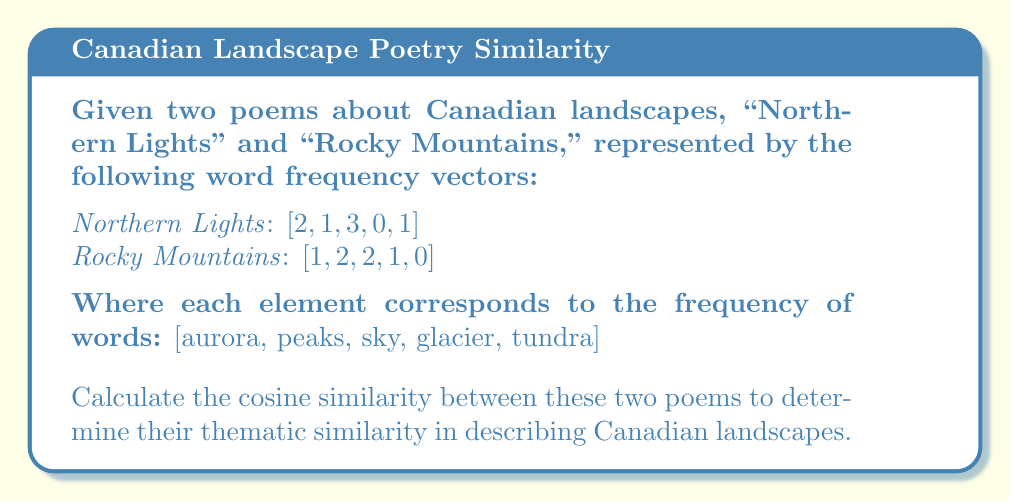Solve this math problem. To calculate the cosine similarity between the two poems, we'll follow these steps:

1. Let $\mathbf{a} = [2, 1, 3, 0, 1]$ represent "Northern Lights" and $\mathbf{b} = [1, 2, 2, 1, 0]$ represent "Rocky Mountains".

2. The cosine similarity is given by the formula:

   $$\text{cosine similarity} = \frac{\mathbf{a} \cdot \mathbf{b}}{\|\mathbf{a}\| \|\mathbf{b}\|}$$

3. Calculate the dot product $\mathbf{a} \cdot \mathbf{b}$:
   $$(2 \times 1) + (1 \times 2) + (3 \times 2) + (0 \times 1) + (1 \times 0) = 2 + 2 + 6 + 0 + 0 = 10$$

4. Calculate $\|\mathbf{a}\|$:
   $$\|\mathbf{a}\| = \sqrt{2^2 + 1^2 + 3^2 + 0^2 + 1^2} = \sqrt{4 + 1 + 9 + 0 + 1} = \sqrt{15} \approx 3.873$$

5. Calculate $\|\mathbf{b}\|$:
   $$\|\mathbf{b}\| = \sqrt{1^2 + 2^2 + 2^2 + 1^2 + 0^2} = \sqrt{1 + 4 + 4 + 1 + 0} = \sqrt{10} \approx 3.162$$

6. Apply the cosine similarity formula:
   $$\text{cosine similarity} = \frac{10}{3.873 \times 3.162} \approx 0.816$$
Answer: 0.816 